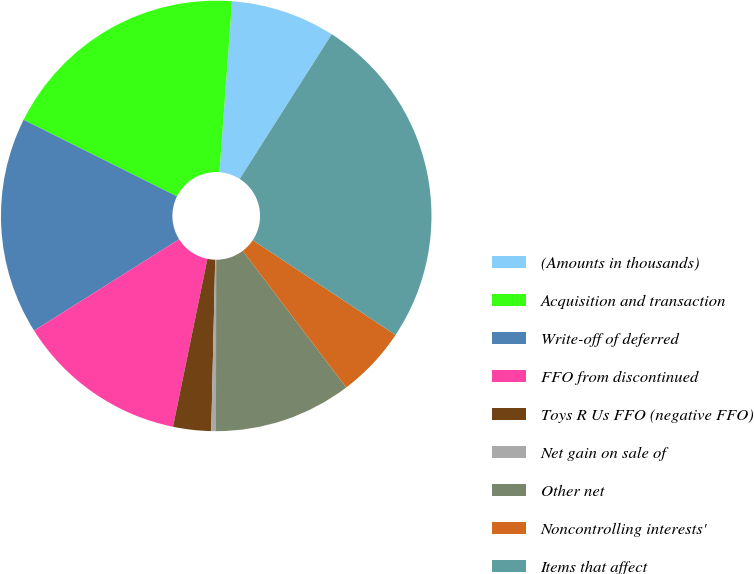<chart> <loc_0><loc_0><loc_500><loc_500><pie_chart><fcel>(Amounts in thousands)<fcel>Acquisition and transaction<fcel>Write-off of deferred<fcel>FFO from discontinued<fcel>Toys R Us FFO (negative FFO)<fcel>Net gain on sale of<fcel>Other net<fcel>Noncontrolling interests'<fcel>Items that affect<nl><fcel>7.84%<fcel>18.81%<fcel>16.31%<fcel>12.84%<fcel>2.85%<fcel>0.35%<fcel>10.34%<fcel>5.35%<fcel>25.32%<nl></chart> 